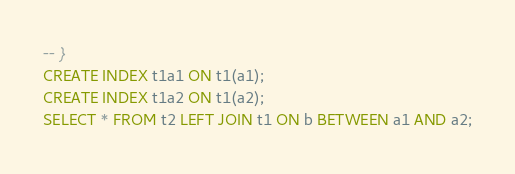<code> <loc_0><loc_0><loc_500><loc_500><_SQL_>-- }
CREATE INDEX t1a1 ON t1(a1);
CREATE INDEX t1a2 ON t1(a2);
SELECT * FROM t2 LEFT JOIN t1 ON b BETWEEN a1 AND a2;</code> 